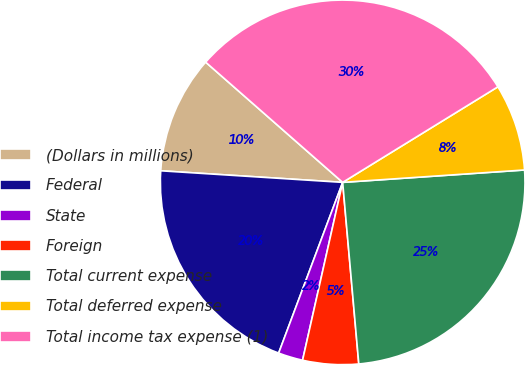<chart> <loc_0><loc_0><loc_500><loc_500><pie_chart><fcel>(Dollars in millions)<fcel>Federal<fcel>State<fcel>Foreign<fcel>Total current expense<fcel>Total deferred expense<fcel>Total income tax expense (1)<nl><fcel>10.45%<fcel>20.3%<fcel>2.18%<fcel>4.94%<fcel>24.67%<fcel>7.7%<fcel>29.75%<nl></chart> 